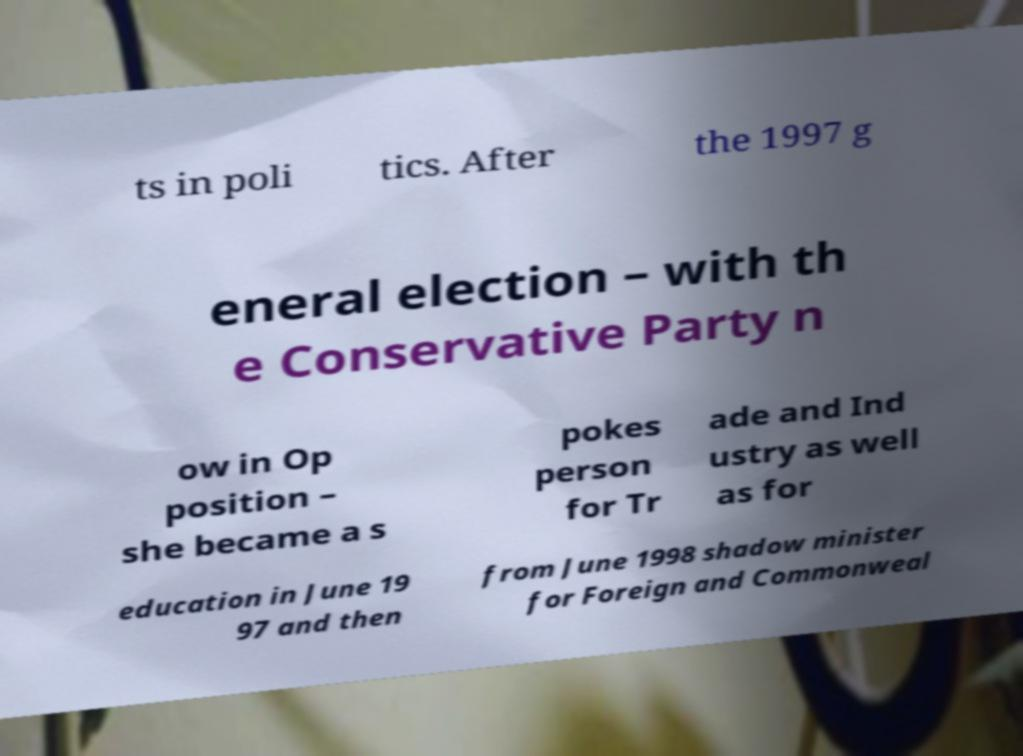There's text embedded in this image that I need extracted. Can you transcribe it verbatim? ts in poli tics. After the 1997 g eneral election – with th e Conservative Party n ow in Op position – she became a s pokes person for Tr ade and Ind ustry as well as for education in June 19 97 and then from June 1998 shadow minister for Foreign and Commonweal 